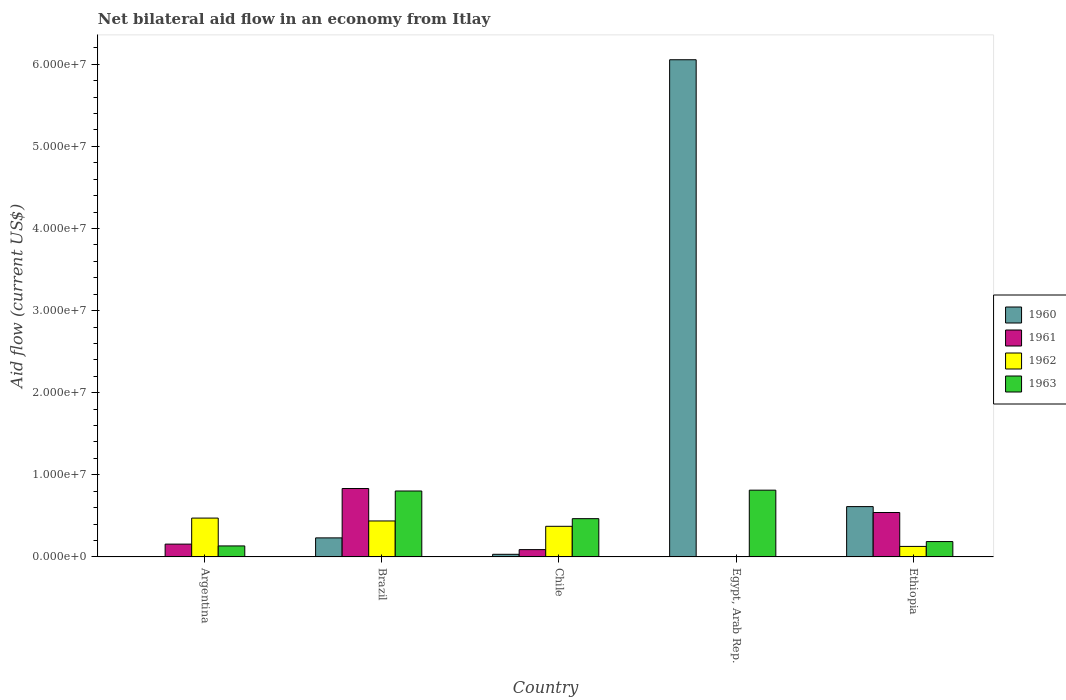How many different coloured bars are there?
Offer a terse response. 4. Are the number of bars per tick equal to the number of legend labels?
Give a very brief answer. No. Are the number of bars on each tick of the X-axis equal?
Your answer should be very brief. No. How many bars are there on the 5th tick from the right?
Offer a terse response. 3. What is the label of the 4th group of bars from the left?
Ensure brevity in your answer.  Egypt, Arab Rep. In how many cases, is the number of bars for a given country not equal to the number of legend labels?
Provide a succinct answer. 2. Across all countries, what is the maximum net bilateral aid flow in 1961?
Ensure brevity in your answer.  8.33e+06. What is the total net bilateral aid flow in 1962 in the graph?
Keep it short and to the point. 1.41e+07. What is the difference between the net bilateral aid flow in 1962 in Argentina and that in Ethiopia?
Keep it short and to the point. 3.45e+06. What is the difference between the net bilateral aid flow in 1962 in Egypt, Arab Rep. and the net bilateral aid flow in 1961 in Brazil?
Provide a short and direct response. -8.33e+06. What is the average net bilateral aid flow in 1963 per country?
Your response must be concise. 4.81e+06. What is the difference between the net bilateral aid flow of/in 1960 and net bilateral aid flow of/in 1963 in Egypt, Arab Rep.?
Make the answer very short. 5.24e+07. What is the ratio of the net bilateral aid flow in 1962 in Chile to that in Ethiopia?
Make the answer very short. 2.91. What is the difference between the highest and the lowest net bilateral aid flow in 1960?
Your response must be concise. 6.06e+07. Is it the case that in every country, the sum of the net bilateral aid flow in 1962 and net bilateral aid flow in 1963 is greater than the sum of net bilateral aid flow in 1961 and net bilateral aid flow in 1960?
Offer a terse response. No. How many bars are there?
Give a very brief answer. 17. Are all the bars in the graph horizontal?
Keep it short and to the point. No. What is the difference between two consecutive major ticks on the Y-axis?
Your answer should be compact. 1.00e+07. Are the values on the major ticks of Y-axis written in scientific E-notation?
Keep it short and to the point. Yes. Does the graph contain grids?
Your answer should be very brief. No. How many legend labels are there?
Ensure brevity in your answer.  4. How are the legend labels stacked?
Provide a short and direct response. Vertical. What is the title of the graph?
Give a very brief answer. Net bilateral aid flow in an economy from Itlay. Does "1982" appear as one of the legend labels in the graph?
Ensure brevity in your answer.  No. What is the label or title of the X-axis?
Make the answer very short. Country. What is the label or title of the Y-axis?
Give a very brief answer. Aid flow (current US$). What is the Aid flow (current US$) in 1960 in Argentina?
Your response must be concise. 0. What is the Aid flow (current US$) in 1961 in Argentina?
Your response must be concise. 1.56e+06. What is the Aid flow (current US$) in 1962 in Argentina?
Your response must be concise. 4.73e+06. What is the Aid flow (current US$) in 1963 in Argentina?
Your response must be concise. 1.34e+06. What is the Aid flow (current US$) of 1960 in Brazil?
Ensure brevity in your answer.  2.32e+06. What is the Aid flow (current US$) in 1961 in Brazil?
Make the answer very short. 8.33e+06. What is the Aid flow (current US$) of 1962 in Brazil?
Your answer should be very brief. 4.38e+06. What is the Aid flow (current US$) in 1963 in Brazil?
Provide a succinct answer. 8.03e+06. What is the Aid flow (current US$) in 1960 in Chile?
Give a very brief answer. 3.20e+05. What is the Aid flow (current US$) in 1961 in Chile?
Ensure brevity in your answer.  8.90e+05. What is the Aid flow (current US$) in 1962 in Chile?
Offer a terse response. 3.73e+06. What is the Aid flow (current US$) in 1963 in Chile?
Provide a short and direct response. 4.66e+06. What is the Aid flow (current US$) of 1960 in Egypt, Arab Rep.?
Make the answer very short. 6.06e+07. What is the Aid flow (current US$) in 1961 in Egypt, Arab Rep.?
Offer a very short reply. 0. What is the Aid flow (current US$) of 1963 in Egypt, Arab Rep.?
Your answer should be very brief. 8.13e+06. What is the Aid flow (current US$) of 1960 in Ethiopia?
Keep it short and to the point. 6.13e+06. What is the Aid flow (current US$) in 1961 in Ethiopia?
Offer a very short reply. 5.41e+06. What is the Aid flow (current US$) of 1962 in Ethiopia?
Your answer should be compact. 1.28e+06. What is the Aid flow (current US$) in 1963 in Ethiopia?
Ensure brevity in your answer.  1.87e+06. Across all countries, what is the maximum Aid flow (current US$) of 1960?
Your answer should be compact. 6.06e+07. Across all countries, what is the maximum Aid flow (current US$) of 1961?
Give a very brief answer. 8.33e+06. Across all countries, what is the maximum Aid flow (current US$) of 1962?
Offer a terse response. 4.73e+06. Across all countries, what is the maximum Aid flow (current US$) in 1963?
Make the answer very short. 8.13e+06. Across all countries, what is the minimum Aid flow (current US$) in 1960?
Your answer should be very brief. 0. Across all countries, what is the minimum Aid flow (current US$) in 1963?
Keep it short and to the point. 1.34e+06. What is the total Aid flow (current US$) of 1960 in the graph?
Your response must be concise. 6.93e+07. What is the total Aid flow (current US$) in 1961 in the graph?
Provide a succinct answer. 1.62e+07. What is the total Aid flow (current US$) in 1962 in the graph?
Your response must be concise. 1.41e+07. What is the total Aid flow (current US$) in 1963 in the graph?
Your response must be concise. 2.40e+07. What is the difference between the Aid flow (current US$) of 1961 in Argentina and that in Brazil?
Ensure brevity in your answer.  -6.77e+06. What is the difference between the Aid flow (current US$) in 1963 in Argentina and that in Brazil?
Your answer should be very brief. -6.69e+06. What is the difference between the Aid flow (current US$) in 1961 in Argentina and that in Chile?
Your answer should be compact. 6.70e+05. What is the difference between the Aid flow (current US$) of 1963 in Argentina and that in Chile?
Your response must be concise. -3.32e+06. What is the difference between the Aid flow (current US$) of 1963 in Argentina and that in Egypt, Arab Rep.?
Your answer should be very brief. -6.79e+06. What is the difference between the Aid flow (current US$) in 1961 in Argentina and that in Ethiopia?
Ensure brevity in your answer.  -3.85e+06. What is the difference between the Aid flow (current US$) of 1962 in Argentina and that in Ethiopia?
Your response must be concise. 3.45e+06. What is the difference between the Aid flow (current US$) in 1963 in Argentina and that in Ethiopia?
Offer a very short reply. -5.30e+05. What is the difference between the Aid flow (current US$) of 1961 in Brazil and that in Chile?
Provide a short and direct response. 7.44e+06. What is the difference between the Aid flow (current US$) of 1962 in Brazil and that in Chile?
Ensure brevity in your answer.  6.50e+05. What is the difference between the Aid flow (current US$) of 1963 in Brazil and that in Chile?
Give a very brief answer. 3.37e+06. What is the difference between the Aid flow (current US$) in 1960 in Brazil and that in Egypt, Arab Rep.?
Your answer should be very brief. -5.82e+07. What is the difference between the Aid flow (current US$) in 1963 in Brazil and that in Egypt, Arab Rep.?
Give a very brief answer. -1.00e+05. What is the difference between the Aid flow (current US$) of 1960 in Brazil and that in Ethiopia?
Your answer should be compact. -3.81e+06. What is the difference between the Aid flow (current US$) of 1961 in Brazil and that in Ethiopia?
Provide a succinct answer. 2.92e+06. What is the difference between the Aid flow (current US$) in 1962 in Brazil and that in Ethiopia?
Your answer should be compact. 3.10e+06. What is the difference between the Aid flow (current US$) in 1963 in Brazil and that in Ethiopia?
Offer a terse response. 6.16e+06. What is the difference between the Aid flow (current US$) of 1960 in Chile and that in Egypt, Arab Rep.?
Keep it short and to the point. -6.02e+07. What is the difference between the Aid flow (current US$) in 1963 in Chile and that in Egypt, Arab Rep.?
Your response must be concise. -3.47e+06. What is the difference between the Aid flow (current US$) of 1960 in Chile and that in Ethiopia?
Your response must be concise. -5.81e+06. What is the difference between the Aid flow (current US$) of 1961 in Chile and that in Ethiopia?
Ensure brevity in your answer.  -4.52e+06. What is the difference between the Aid flow (current US$) of 1962 in Chile and that in Ethiopia?
Make the answer very short. 2.45e+06. What is the difference between the Aid flow (current US$) of 1963 in Chile and that in Ethiopia?
Your response must be concise. 2.79e+06. What is the difference between the Aid flow (current US$) of 1960 in Egypt, Arab Rep. and that in Ethiopia?
Your response must be concise. 5.44e+07. What is the difference between the Aid flow (current US$) of 1963 in Egypt, Arab Rep. and that in Ethiopia?
Offer a very short reply. 6.26e+06. What is the difference between the Aid flow (current US$) of 1961 in Argentina and the Aid flow (current US$) of 1962 in Brazil?
Keep it short and to the point. -2.82e+06. What is the difference between the Aid flow (current US$) of 1961 in Argentina and the Aid flow (current US$) of 1963 in Brazil?
Make the answer very short. -6.47e+06. What is the difference between the Aid flow (current US$) in 1962 in Argentina and the Aid flow (current US$) in 1963 in Brazil?
Provide a short and direct response. -3.30e+06. What is the difference between the Aid flow (current US$) in 1961 in Argentina and the Aid flow (current US$) in 1962 in Chile?
Offer a very short reply. -2.17e+06. What is the difference between the Aid flow (current US$) of 1961 in Argentina and the Aid flow (current US$) of 1963 in Chile?
Your response must be concise. -3.10e+06. What is the difference between the Aid flow (current US$) in 1961 in Argentina and the Aid flow (current US$) in 1963 in Egypt, Arab Rep.?
Your response must be concise. -6.57e+06. What is the difference between the Aid flow (current US$) in 1962 in Argentina and the Aid flow (current US$) in 1963 in Egypt, Arab Rep.?
Provide a succinct answer. -3.40e+06. What is the difference between the Aid flow (current US$) in 1961 in Argentina and the Aid flow (current US$) in 1962 in Ethiopia?
Your answer should be compact. 2.80e+05. What is the difference between the Aid flow (current US$) in 1961 in Argentina and the Aid flow (current US$) in 1963 in Ethiopia?
Your answer should be very brief. -3.10e+05. What is the difference between the Aid flow (current US$) of 1962 in Argentina and the Aid flow (current US$) of 1963 in Ethiopia?
Provide a short and direct response. 2.86e+06. What is the difference between the Aid flow (current US$) of 1960 in Brazil and the Aid flow (current US$) of 1961 in Chile?
Your answer should be very brief. 1.43e+06. What is the difference between the Aid flow (current US$) in 1960 in Brazil and the Aid flow (current US$) in 1962 in Chile?
Offer a terse response. -1.41e+06. What is the difference between the Aid flow (current US$) of 1960 in Brazil and the Aid flow (current US$) of 1963 in Chile?
Make the answer very short. -2.34e+06. What is the difference between the Aid flow (current US$) of 1961 in Brazil and the Aid flow (current US$) of 1962 in Chile?
Provide a succinct answer. 4.60e+06. What is the difference between the Aid flow (current US$) of 1961 in Brazil and the Aid flow (current US$) of 1963 in Chile?
Your answer should be very brief. 3.67e+06. What is the difference between the Aid flow (current US$) in 1962 in Brazil and the Aid flow (current US$) in 1963 in Chile?
Offer a terse response. -2.80e+05. What is the difference between the Aid flow (current US$) of 1960 in Brazil and the Aid flow (current US$) of 1963 in Egypt, Arab Rep.?
Keep it short and to the point. -5.81e+06. What is the difference between the Aid flow (current US$) of 1961 in Brazil and the Aid flow (current US$) of 1963 in Egypt, Arab Rep.?
Your response must be concise. 2.00e+05. What is the difference between the Aid flow (current US$) in 1962 in Brazil and the Aid flow (current US$) in 1963 in Egypt, Arab Rep.?
Provide a succinct answer. -3.75e+06. What is the difference between the Aid flow (current US$) in 1960 in Brazil and the Aid flow (current US$) in 1961 in Ethiopia?
Your answer should be compact. -3.09e+06. What is the difference between the Aid flow (current US$) in 1960 in Brazil and the Aid flow (current US$) in 1962 in Ethiopia?
Give a very brief answer. 1.04e+06. What is the difference between the Aid flow (current US$) of 1961 in Brazil and the Aid flow (current US$) of 1962 in Ethiopia?
Your response must be concise. 7.05e+06. What is the difference between the Aid flow (current US$) of 1961 in Brazil and the Aid flow (current US$) of 1963 in Ethiopia?
Offer a terse response. 6.46e+06. What is the difference between the Aid flow (current US$) in 1962 in Brazil and the Aid flow (current US$) in 1963 in Ethiopia?
Provide a succinct answer. 2.51e+06. What is the difference between the Aid flow (current US$) of 1960 in Chile and the Aid flow (current US$) of 1963 in Egypt, Arab Rep.?
Provide a short and direct response. -7.81e+06. What is the difference between the Aid flow (current US$) of 1961 in Chile and the Aid flow (current US$) of 1963 in Egypt, Arab Rep.?
Your answer should be compact. -7.24e+06. What is the difference between the Aid flow (current US$) of 1962 in Chile and the Aid flow (current US$) of 1963 in Egypt, Arab Rep.?
Your response must be concise. -4.40e+06. What is the difference between the Aid flow (current US$) of 1960 in Chile and the Aid flow (current US$) of 1961 in Ethiopia?
Your answer should be very brief. -5.09e+06. What is the difference between the Aid flow (current US$) of 1960 in Chile and the Aid flow (current US$) of 1962 in Ethiopia?
Keep it short and to the point. -9.60e+05. What is the difference between the Aid flow (current US$) in 1960 in Chile and the Aid flow (current US$) in 1963 in Ethiopia?
Offer a terse response. -1.55e+06. What is the difference between the Aid flow (current US$) in 1961 in Chile and the Aid flow (current US$) in 1962 in Ethiopia?
Offer a very short reply. -3.90e+05. What is the difference between the Aid flow (current US$) of 1961 in Chile and the Aid flow (current US$) of 1963 in Ethiopia?
Your answer should be compact. -9.80e+05. What is the difference between the Aid flow (current US$) of 1962 in Chile and the Aid flow (current US$) of 1963 in Ethiopia?
Offer a terse response. 1.86e+06. What is the difference between the Aid flow (current US$) of 1960 in Egypt, Arab Rep. and the Aid flow (current US$) of 1961 in Ethiopia?
Offer a very short reply. 5.51e+07. What is the difference between the Aid flow (current US$) of 1960 in Egypt, Arab Rep. and the Aid flow (current US$) of 1962 in Ethiopia?
Your answer should be very brief. 5.93e+07. What is the difference between the Aid flow (current US$) in 1960 in Egypt, Arab Rep. and the Aid flow (current US$) in 1963 in Ethiopia?
Give a very brief answer. 5.87e+07. What is the average Aid flow (current US$) in 1960 per country?
Provide a succinct answer. 1.39e+07. What is the average Aid flow (current US$) in 1961 per country?
Offer a very short reply. 3.24e+06. What is the average Aid flow (current US$) in 1962 per country?
Keep it short and to the point. 2.82e+06. What is the average Aid flow (current US$) of 1963 per country?
Give a very brief answer. 4.81e+06. What is the difference between the Aid flow (current US$) in 1961 and Aid flow (current US$) in 1962 in Argentina?
Provide a succinct answer. -3.17e+06. What is the difference between the Aid flow (current US$) of 1962 and Aid flow (current US$) of 1963 in Argentina?
Keep it short and to the point. 3.39e+06. What is the difference between the Aid flow (current US$) in 1960 and Aid flow (current US$) in 1961 in Brazil?
Offer a very short reply. -6.01e+06. What is the difference between the Aid flow (current US$) of 1960 and Aid flow (current US$) of 1962 in Brazil?
Keep it short and to the point. -2.06e+06. What is the difference between the Aid flow (current US$) in 1960 and Aid flow (current US$) in 1963 in Brazil?
Provide a short and direct response. -5.71e+06. What is the difference between the Aid flow (current US$) in 1961 and Aid flow (current US$) in 1962 in Brazil?
Make the answer very short. 3.95e+06. What is the difference between the Aid flow (current US$) in 1961 and Aid flow (current US$) in 1963 in Brazil?
Your response must be concise. 3.00e+05. What is the difference between the Aid flow (current US$) of 1962 and Aid flow (current US$) of 1963 in Brazil?
Give a very brief answer. -3.65e+06. What is the difference between the Aid flow (current US$) of 1960 and Aid flow (current US$) of 1961 in Chile?
Your response must be concise. -5.70e+05. What is the difference between the Aid flow (current US$) of 1960 and Aid flow (current US$) of 1962 in Chile?
Provide a short and direct response. -3.41e+06. What is the difference between the Aid flow (current US$) in 1960 and Aid flow (current US$) in 1963 in Chile?
Your response must be concise. -4.34e+06. What is the difference between the Aid flow (current US$) of 1961 and Aid flow (current US$) of 1962 in Chile?
Keep it short and to the point. -2.84e+06. What is the difference between the Aid flow (current US$) in 1961 and Aid flow (current US$) in 1963 in Chile?
Offer a very short reply. -3.77e+06. What is the difference between the Aid flow (current US$) in 1962 and Aid flow (current US$) in 1963 in Chile?
Make the answer very short. -9.30e+05. What is the difference between the Aid flow (current US$) of 1960 and Aid flow (current US$) of 1963 in Egypt, Arab Rep.?
Offer a terse response. 5.24e+07. What is the difference between the Aid flow (current US$) in 1960 and Aid flow (current US$) in 1961 in Ethiopia?
Your answer should be compact. 7.20e+05. What is the difference between the Aid flow (current US$) of 1960 and Aid flow (current US$) of 1962 in Ethiopia?
Provide a succinct answer. 4.85e+06. What is the difference between the Aid flow (current US$) in 1960 and Aid flow (current US$) in 1963 in Ethiopia?
Make the answer very short. 4.26e+06. What is the difference between the Aid flow (current US$) of 1961 and Aid flow (current US$) of 1962 in Ethiopia?
Give a very brief answer. 4.13e+06. What is the difference between the Aid flow (current US$) of 1961 and Aid flow (current US$) of 1963 in Ethiopia?
Provide a short and direct response. 3.54e+06. What is the difference between the Aid flow (current US$) in 1962 and Aid flow (current US$) in 1963 in Ethiopia?
Your answer should be compact. -5.90e+05. What is the ratio of the Aid flow (current US$) of 1961 in Argentina to that in Brazil?
Ensure brevity in your answer.  0.19. What is the ratio of the Aid flow (current US$) of 1962 in Argentina to that in Brazil?
Your answer should be compact. 1.08. What is the ratio of the Aid flow (current US$) of 1963 in Argentina to that in Brazil?
Provide a succinct answer. 0.17. What is the ratio of the Aid flow (current US$) of 1961 in Argentina to that in Chile?
Offer a very short reply. 1.75. What is the ratio of the Aid flow (current US$) in 1962 in Argentina to that in Chile?
Your response must be concise. 1.27. What is the ratio of the Aid flow (current US$) of 1963 in Argentina to that in Chile?
Your answer should be very brief. 0.29. What is the ratio of the Aid flow (current US$) in 1963 in Argentina to that in Egypt, Arab Rep.?
Provide a short and direct response. 0.16. What is the ratio of the Aid flow (current US$) in 1961 in Argentina to that in Ethiopia?
Provide a short and direct response. 0.29. What is the ratio of the Aid flow (current US$) in 1962 in Argentina to that in Ethiopia?
Make the answer very short. 3.7. What is the ratio of the Aid flow (current US$) in 1963 in Argentina to that in Ethiopia?
Keep it short and to the point. 0.72. What is the ratio of the Aid flow (current US$) in 1960 in Brazil to that in Chile?
Ensure brevity in your answer.  7.25. What is the ratio of the Aid flow (current US$) in 1961 in Brazil to that in Chile?
Give a very brief answer. 9.36. What is the ratio of the Aid flow (current US$) in 1962 in Brazil to that in Chile?
Offer a very short reply. 1.17. What is the ratio of the Aid flow (current US$) of 1963 in Brazil to that in Chile?
Your answer should be very brief. 1.72. What is the ratio of the Aid flow (current US$) of 1960 in Brazil to that in Egypt, Arab Rep.?
Provide a succinct answer. 0.04. What is the ratio of the Aid flow (current US$) of 1960 in Brazil to that in Ethiopia?
Offer a very short reply. 0.38. What is the ratio of the Aid flow (current US$) in 1961 in Brazil to that in Ethiopia?
Offer a terse response. 1.54. What is the ratio of the Aid flow (current US$) in 1962 in Brazil to that in Ethiopia?
Make the answer very short. 3.42. What is the ratio of the Aid flow (current US$) of 1963 in Brazil to that in Ethiopia?
Offer a terse response. 4.29. What is the ratio of the Aid flow (current US$) of 1960 in Chile to that in Egypt, Arab Rep.?
Keep it short and to the point. 0.01. What is the ratio of the Aid flow (current US$) in 1963 in Chile to that in Egypt, Arab Rep.?
Provide a short and direct response. 0.57. What is the ratio of the Aid flow (current US$) of 1960 in Chile to that in Ethiopia?
Provide a short and direct response. 0.05. What is the ratio of the Aid flow (current US$) of 1961 in Chile to that in Ethiopia?
Your answer should be compact. 0.16. What is the ratio of the Aid flow (current US$) in 1962 in Chile to that in Ethiopia?
Make the answer very short. 2.91. What is the ratio of the Aid flow (current US$) of 1963 in Chile to that in Ethiopia?
Your response must be concise. 2.49. What is the ratio of the Aid flow (current US$) of 1960 in Egypt, Arab Rep. to that in Ethiopia?
Your response must be concise. 9.88. What is the ratio of the Aid flow (current US$) of 1963 in Egypt, Arab Rep. to that in Ethiopia?
Provide a short and direct response. 4.35. What is the difference between the highest and the second highest Aid flow (current US$) of 1960?
Provide a short and direct response. 5.44e+07. What is the difference between the highest and the second highest Aid flow (current US$) in 1961?
Keep it short and to the point. 2.92e+06. What is the difference between the highest and the lowest Aid flow (current US$) of 1960?
Provide a succinct answer. 6.06e+07. What is the difference between the highest and the lowest Aid flow (current US$) in 1961?
Your response must be concise. 8.33e+06. What is the difference between the highest and the lowest Aid flow (current US$) of 1962?
Give a very brief answer. 4.73e+06. What is the difference between the highest and the lowest Aid flow (current US$) in 1963?
Provide a short and direct response. 6.79e+06. 